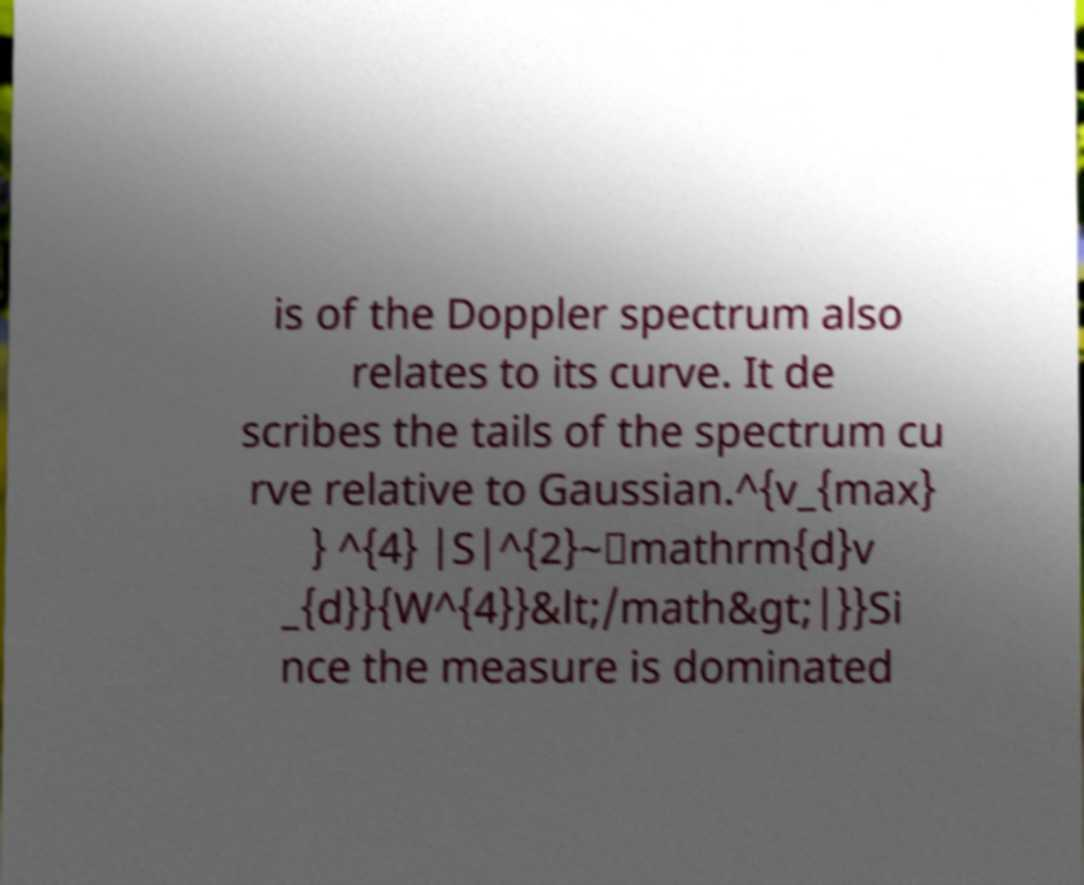Can you accurately transcribe the text from the provided image for me? is of the Doppler spectrum also relates to its curve. It de scribes the tails of the spectrum cu rve relative to Gaussian.^{v_{max} } ^{4} |S|^{2}~\mathrm{d}v _{d}}{W^{4}}&lt;/math&gt;|}}Si nce the measure is dominated 